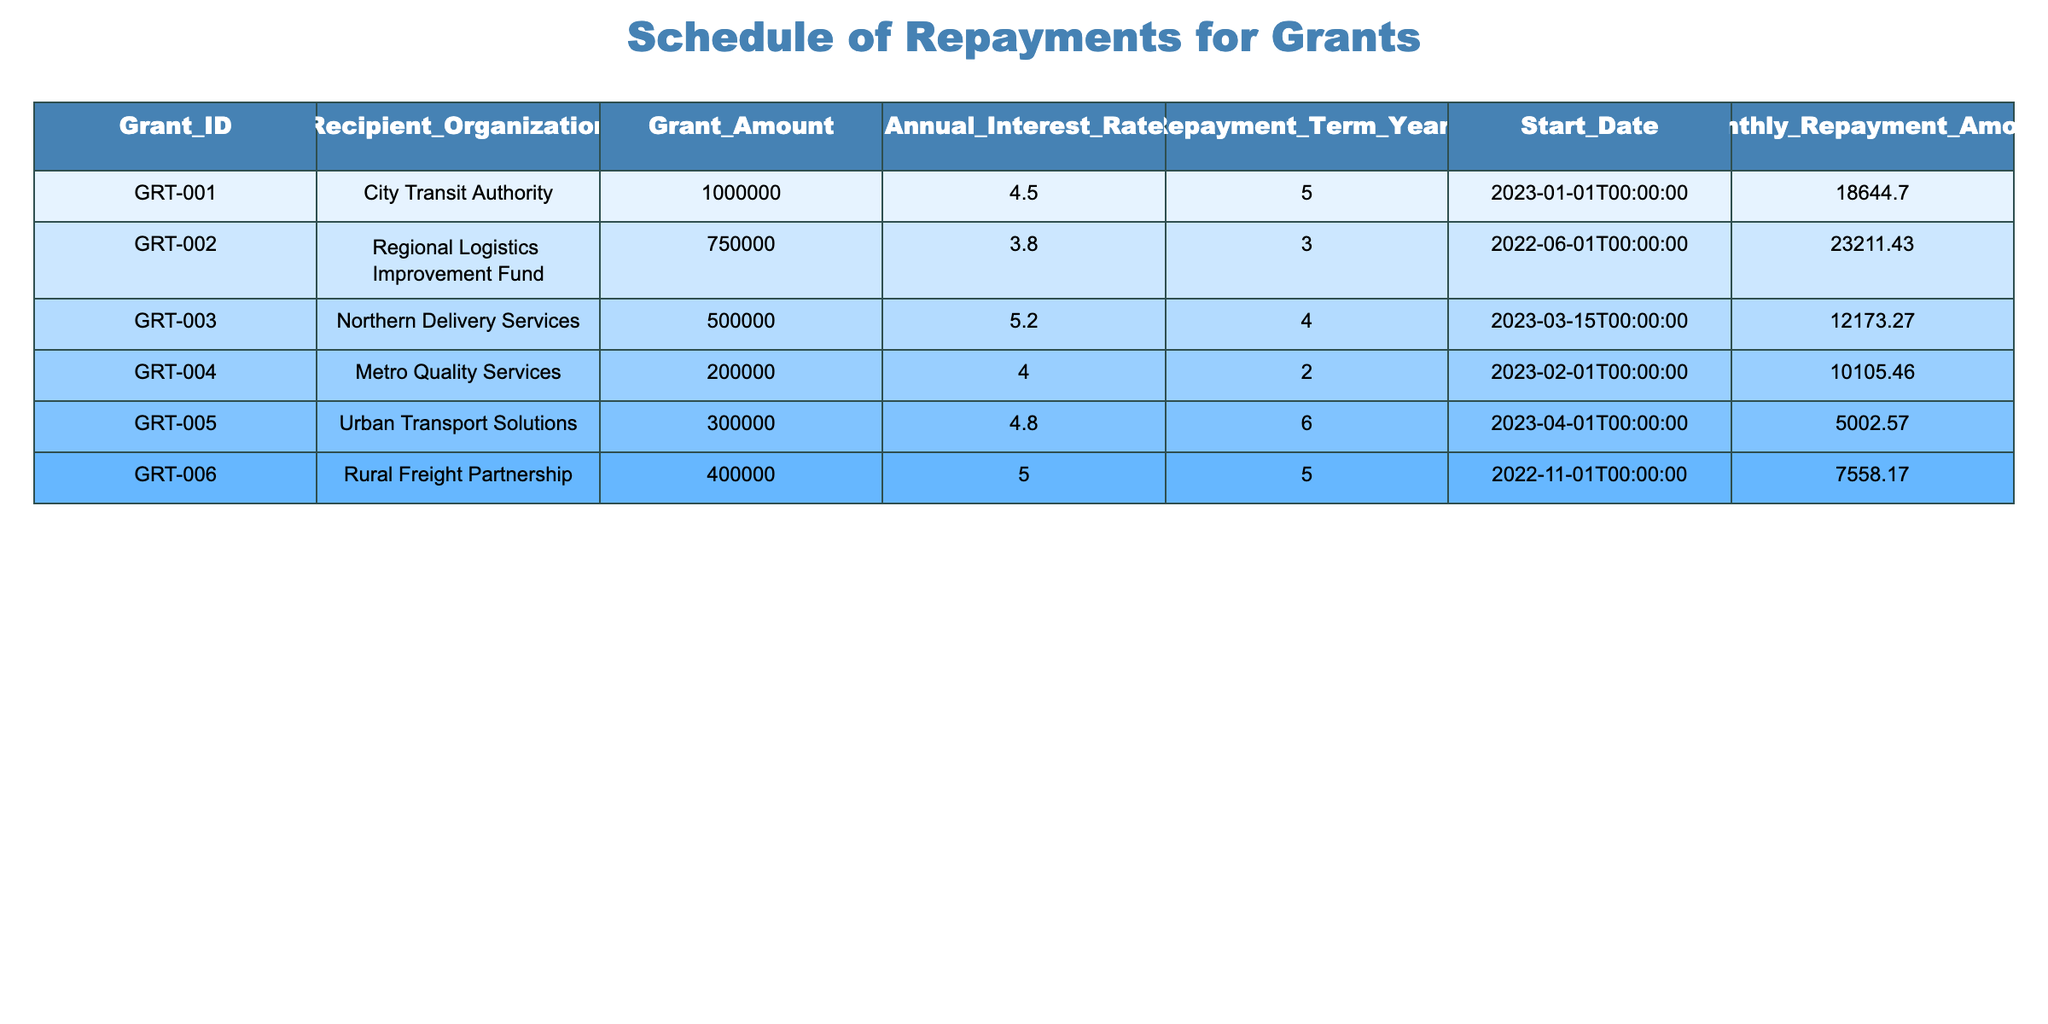What is the total grant amount issued to all organizations? To find the total grant amount, we add up the values from the Grant_Amount column: 1000000 + 750000 + 500000 + 200000 + 300000 + 400000 = 3200000.
Answer: 3200000 Which organization has the highest monthly repayment amount? Looking at the Monthly_Repayment_Amount column, City Transit Authority has the highest value of 18644.70.
Answer: City Transit Authority Is the annual interest rate for Northern Delivery Services higher than 5%? Northern Delivery Services has an annual interest rate of 5.2%, which is indeed higher than 5%.
Answer: Yes What is the average monthly repayment amount across all grants? To find the average, we sum the monthly repayments: (18644.70 + 23211.43 + 12173.27 + 10105.46 + 5002.57 + 7558.17) = 72095.60, then divide by the number of grants (6). Therefore, the average monthly repayment is 72095.60 / 6 = 12016.00.
Answer: 12016.00 How many organizations have repayment terms of more than 4 years? By inspecting the Repayment_Term_Years column, we find that Urban Transport Solutions (6 years), Rural Freight Partnership (5 years), City Transit Authority (5 years), and Northern Delivery Services (4 years) are included. Hence, there are 3 organizations with terms greater than 4 years.
Answer: 3 